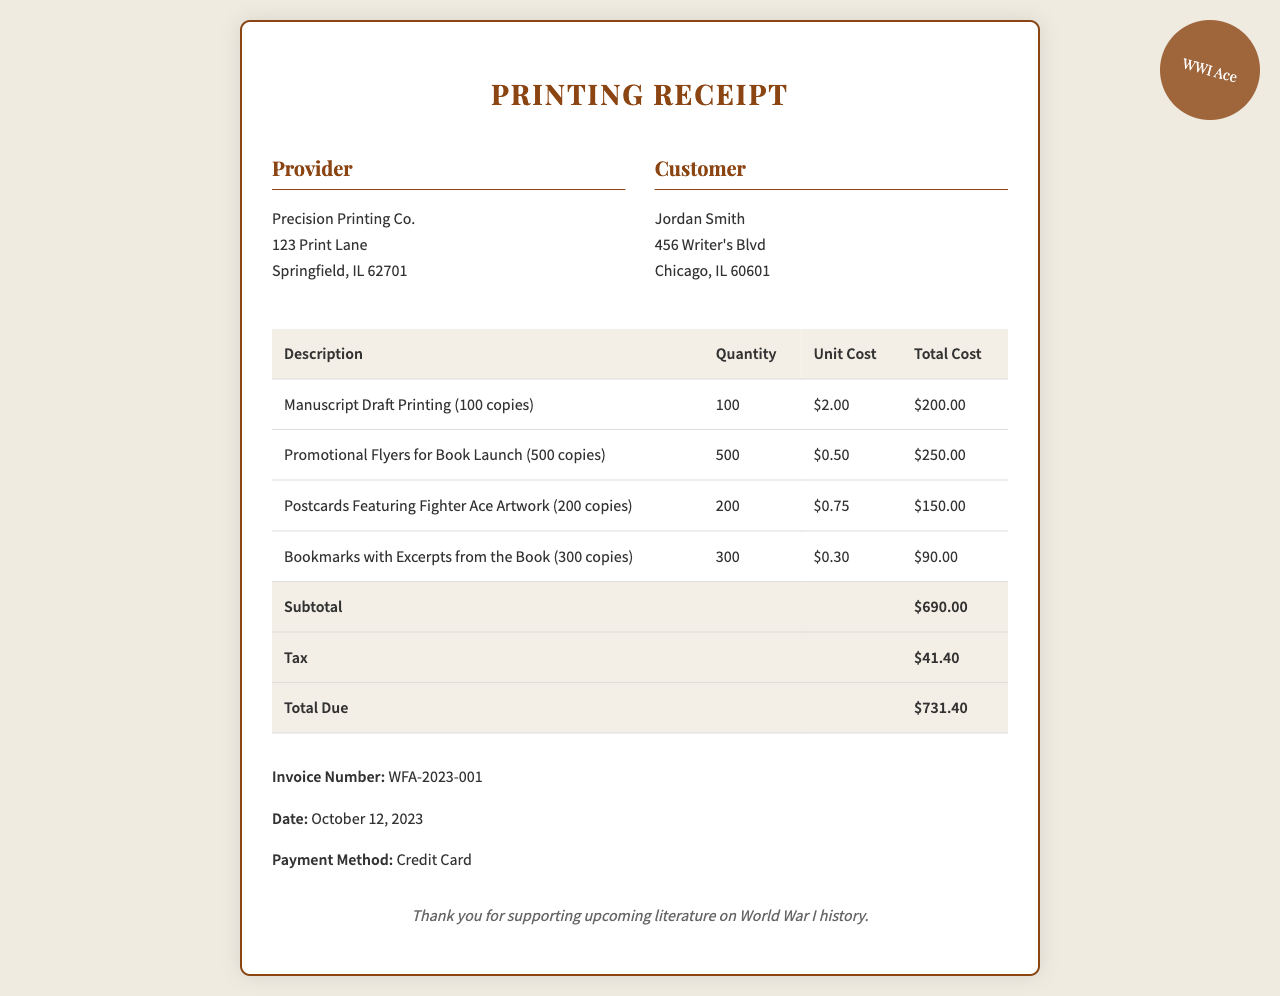What is the name of the provider? The provider is listed at the top of the receipt as "Precision Printing Co."
Answer: Precision Printing Co What is the date of the receipt? The date is indicated near the bottom of the document.
Answer: October 12, 2023 How many promotional flyers were printed? This information is found in the description list under the promotional materials.
Answer: 500 copies What is the total cost of the manuscript draft printing? The total cost for the manuscript draft printing is listed in the corresponding row of the table.
Answer: $200.00 What is the subtotal before tax? The subtotal is specified in the total row of the receipt just before tax is applied.
Answer: $690.00 How much tax was charged? The tax amount is explicitly stated in the total section of the document.
Answer: $41.40 What is the invoice number? The invoice number is provided in a specific line towards the bottom of the receipt.
Answer: WFA-2023-001 What method of payment was used? The payment method is indicated near the end of the document after the total due.
Answer: Credit Card What are the bookmarks printed with? The description of the bookmarks shows what is featured on them.
Answer: Excerpts from the Book 